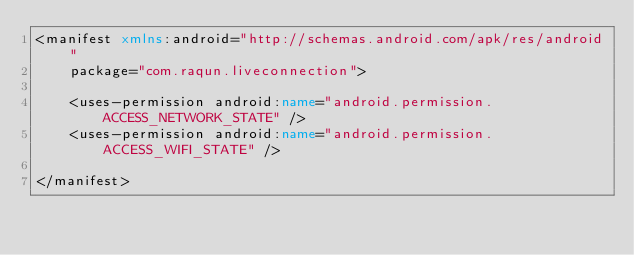<code> <loc_0><loc_0><loc_500><loc_500><_XML_><manifest xmlns:android="http://schemas.android.com/apk/res/android"
    package="com.raqun.liveconnection">

    <uses-permission android:name="android.permission.ACCESS_NETWORK_STATE" />
    <uses-permission android:name="android.permission.ACCESS_WIFI_STATE" />

</manifest>
</code> 